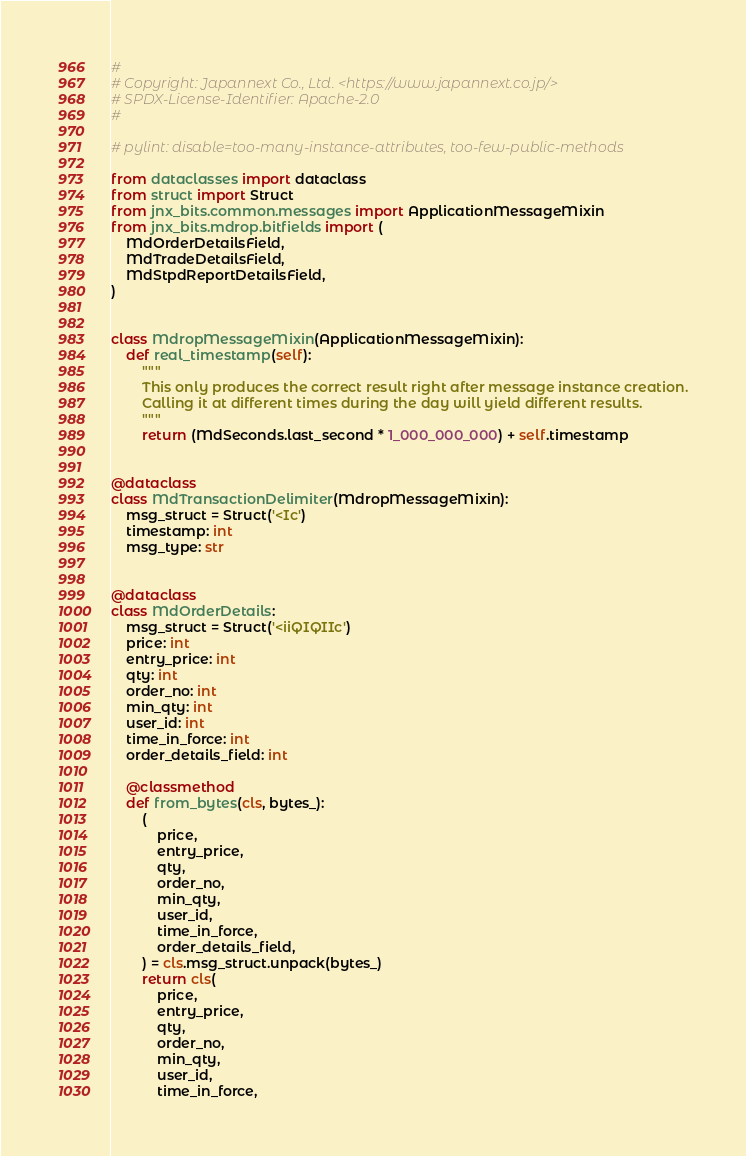<code> <loc_0><loc_0><loc_500><loc_500><_Python_>#
# Copyright: Japannext Co., Ltd. <https://www.japannext.co.jp/>
# SPDX-License-Identifier: Apache-2.0
#

# pylint: disable=too-many-instance-attributes, too-few-public-methods

from dataclasses import dataclass
from struct import Struct
from jnx_bits.common.messages import ApplicationMessageMixin
from jnx_bits.mdrop.bitfields import (
    MdOrderDetailsField,
    MdTradeDetailsField,
    MdStpdReportDetailsField,
)


class MdropMessageMixin(ApplicationMessageMixin):
    def real_timestamp(self):
        """
        This only produces the correct result right after message instance creation.
        Calling it at different times during the day will yield different results.
        """
        return (MdSeconds.last_second * 1_000_000_000) + self.timestamp


@dataclass
class MdTransactionDelimiter(MdropMessageMixin):
    msg_struct = Struct('<Ic')
    timestamp: int
    msg_type: str


@dataclass
class MdOrderDetails:
    msg_struct = Struct('<iiQIQIIc')
    price: int
    entry_price: int
    qty: int
    order_no: int
    min_qty: int
    user_id: int
    time_in_force: int
    order_details_field: int

    @classmethod
    def from_bytes(cls, bytes_):
        (
            price,
            entry_price,
            qty,
            order_no,
            min_qty,
            user_id,
            time_in_force,
            order_details_field,
        ) = cls.msg_struct.unpack(bytes_)
        return cls(
            price,
            entry_price,
            qty,
            order_no,
            min_qty,
            user_id,
            time_in_force,</code> 